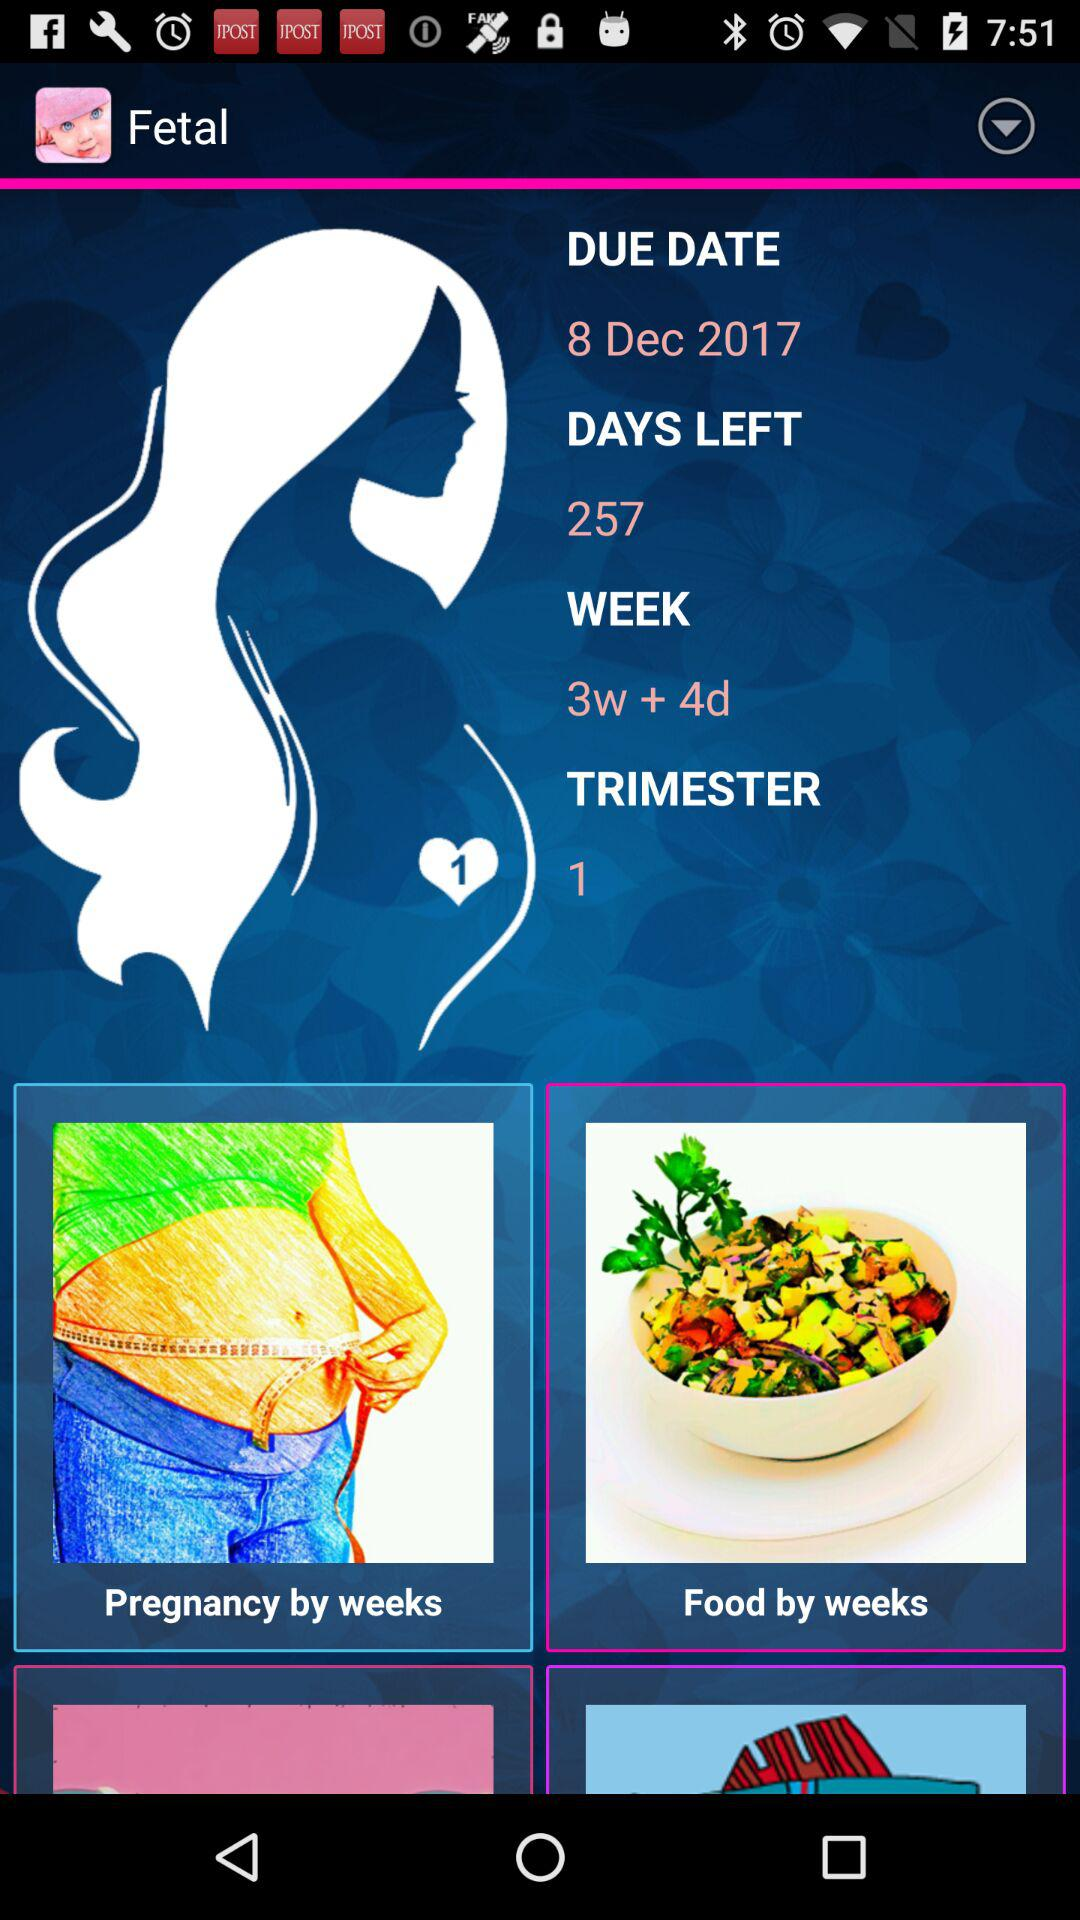What is the name of the application? The name of the application is "Fetal". 